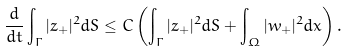Convert formula to latex. <formula><loc_0><loc_0><loc_500><loc_500>\frac { d } { d t } \int _ { \Gamma } | z _ { + } | ^ { 2 } d S \leq C \left ( \int _ { \Gamma } | z _ { + } | ^ { 2 } d S + \int _ { \Omega } | w _ { + } | ^ { 2 } d x \right ) .</formula> 